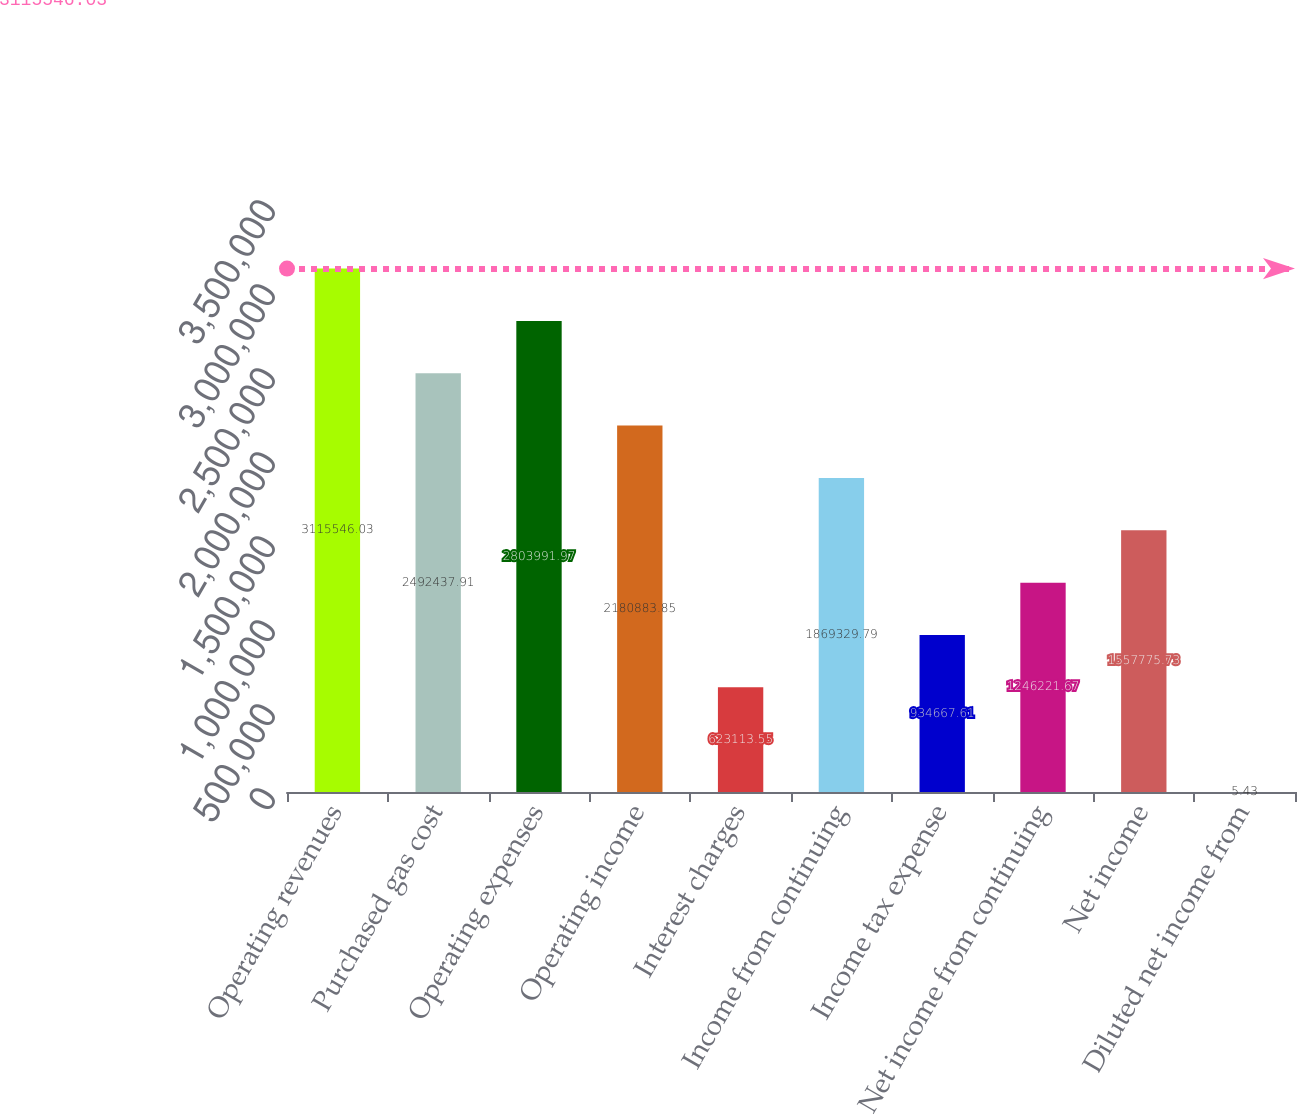<chart> <loc_0><loc_0><loc_500><loc_500><bar_chart><fcel>Operating revenues<fcel>Purchased gas cost<fcel>Operating expenses<fcel>Operating income<fcel>Interest charges<fcel>Income from continuing<fcel>Income tax expense<fcel>Net income from continuing<fcel>Net income<fcel>Diluted net income from<nl><fcel>3.11555e+06<fcel>2.49244e+06<fcel>2.80399e+06<fcel>2.18088e+06<fcel>623114<fcel>1.86933e+06<fcel>934668<fcel>1.24622e+06<fcel>1.55778e+06<fcel>5.43<nl></chart> 